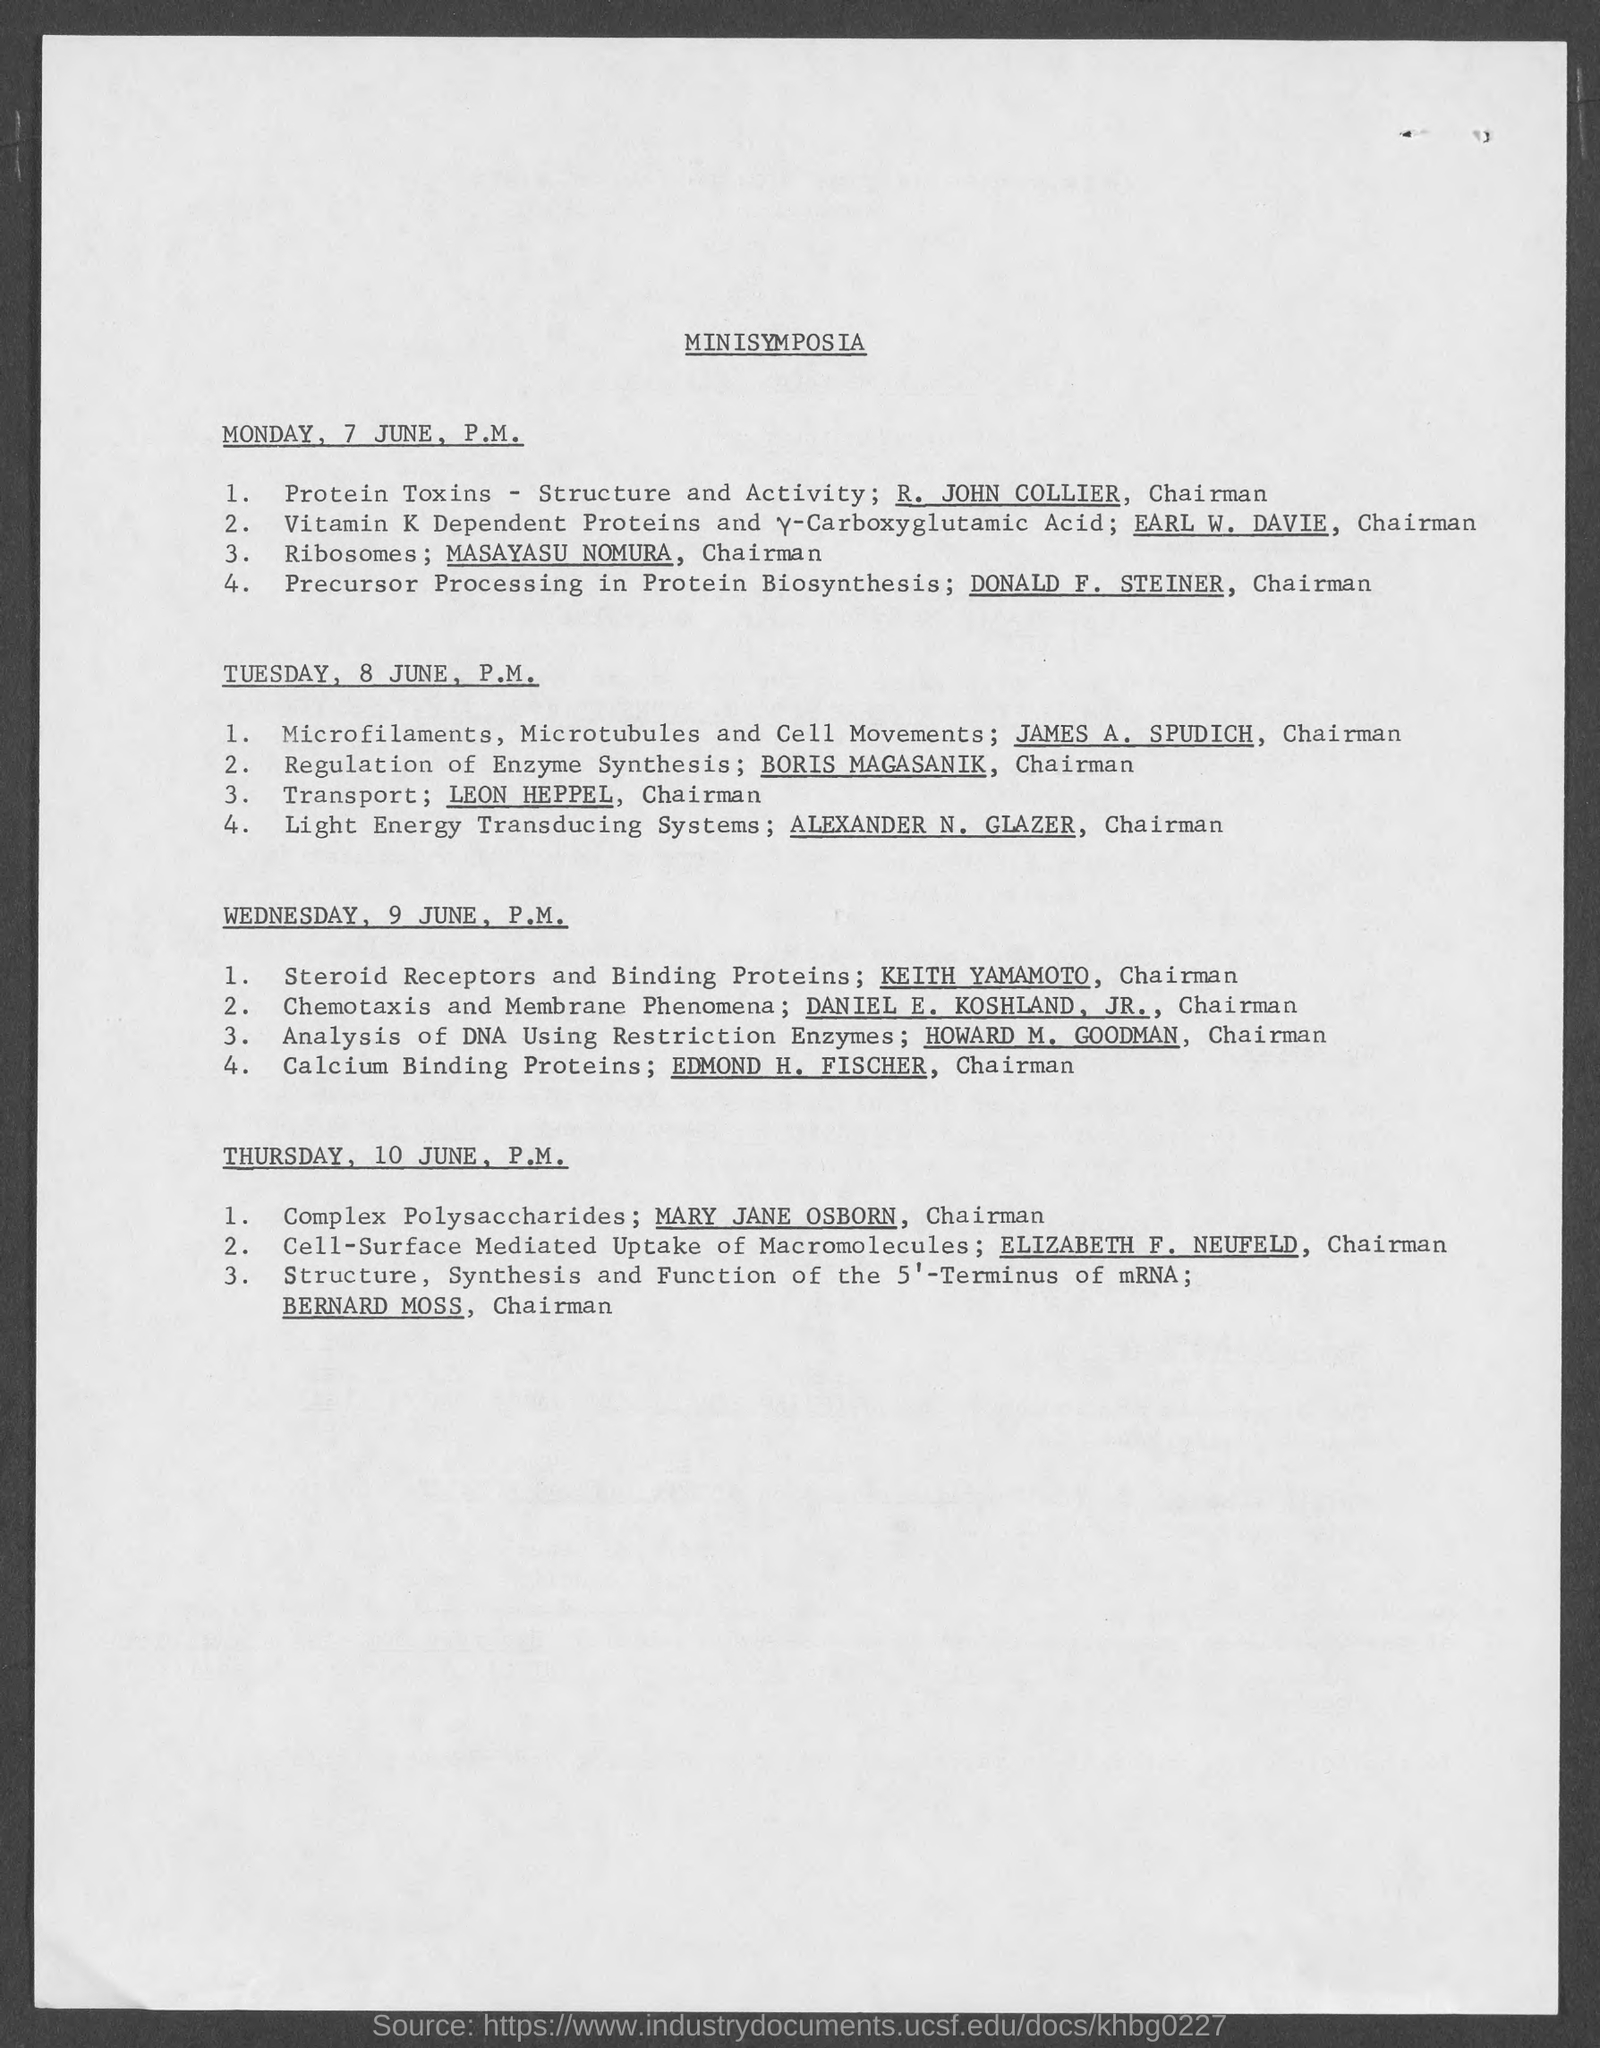Indicate a few pertinent items in this graphic. The session for calcium binding proteins is conducted by Edmond H. Fischer. The title of the document is [What is the Title of the document? Minisymposia..]. 